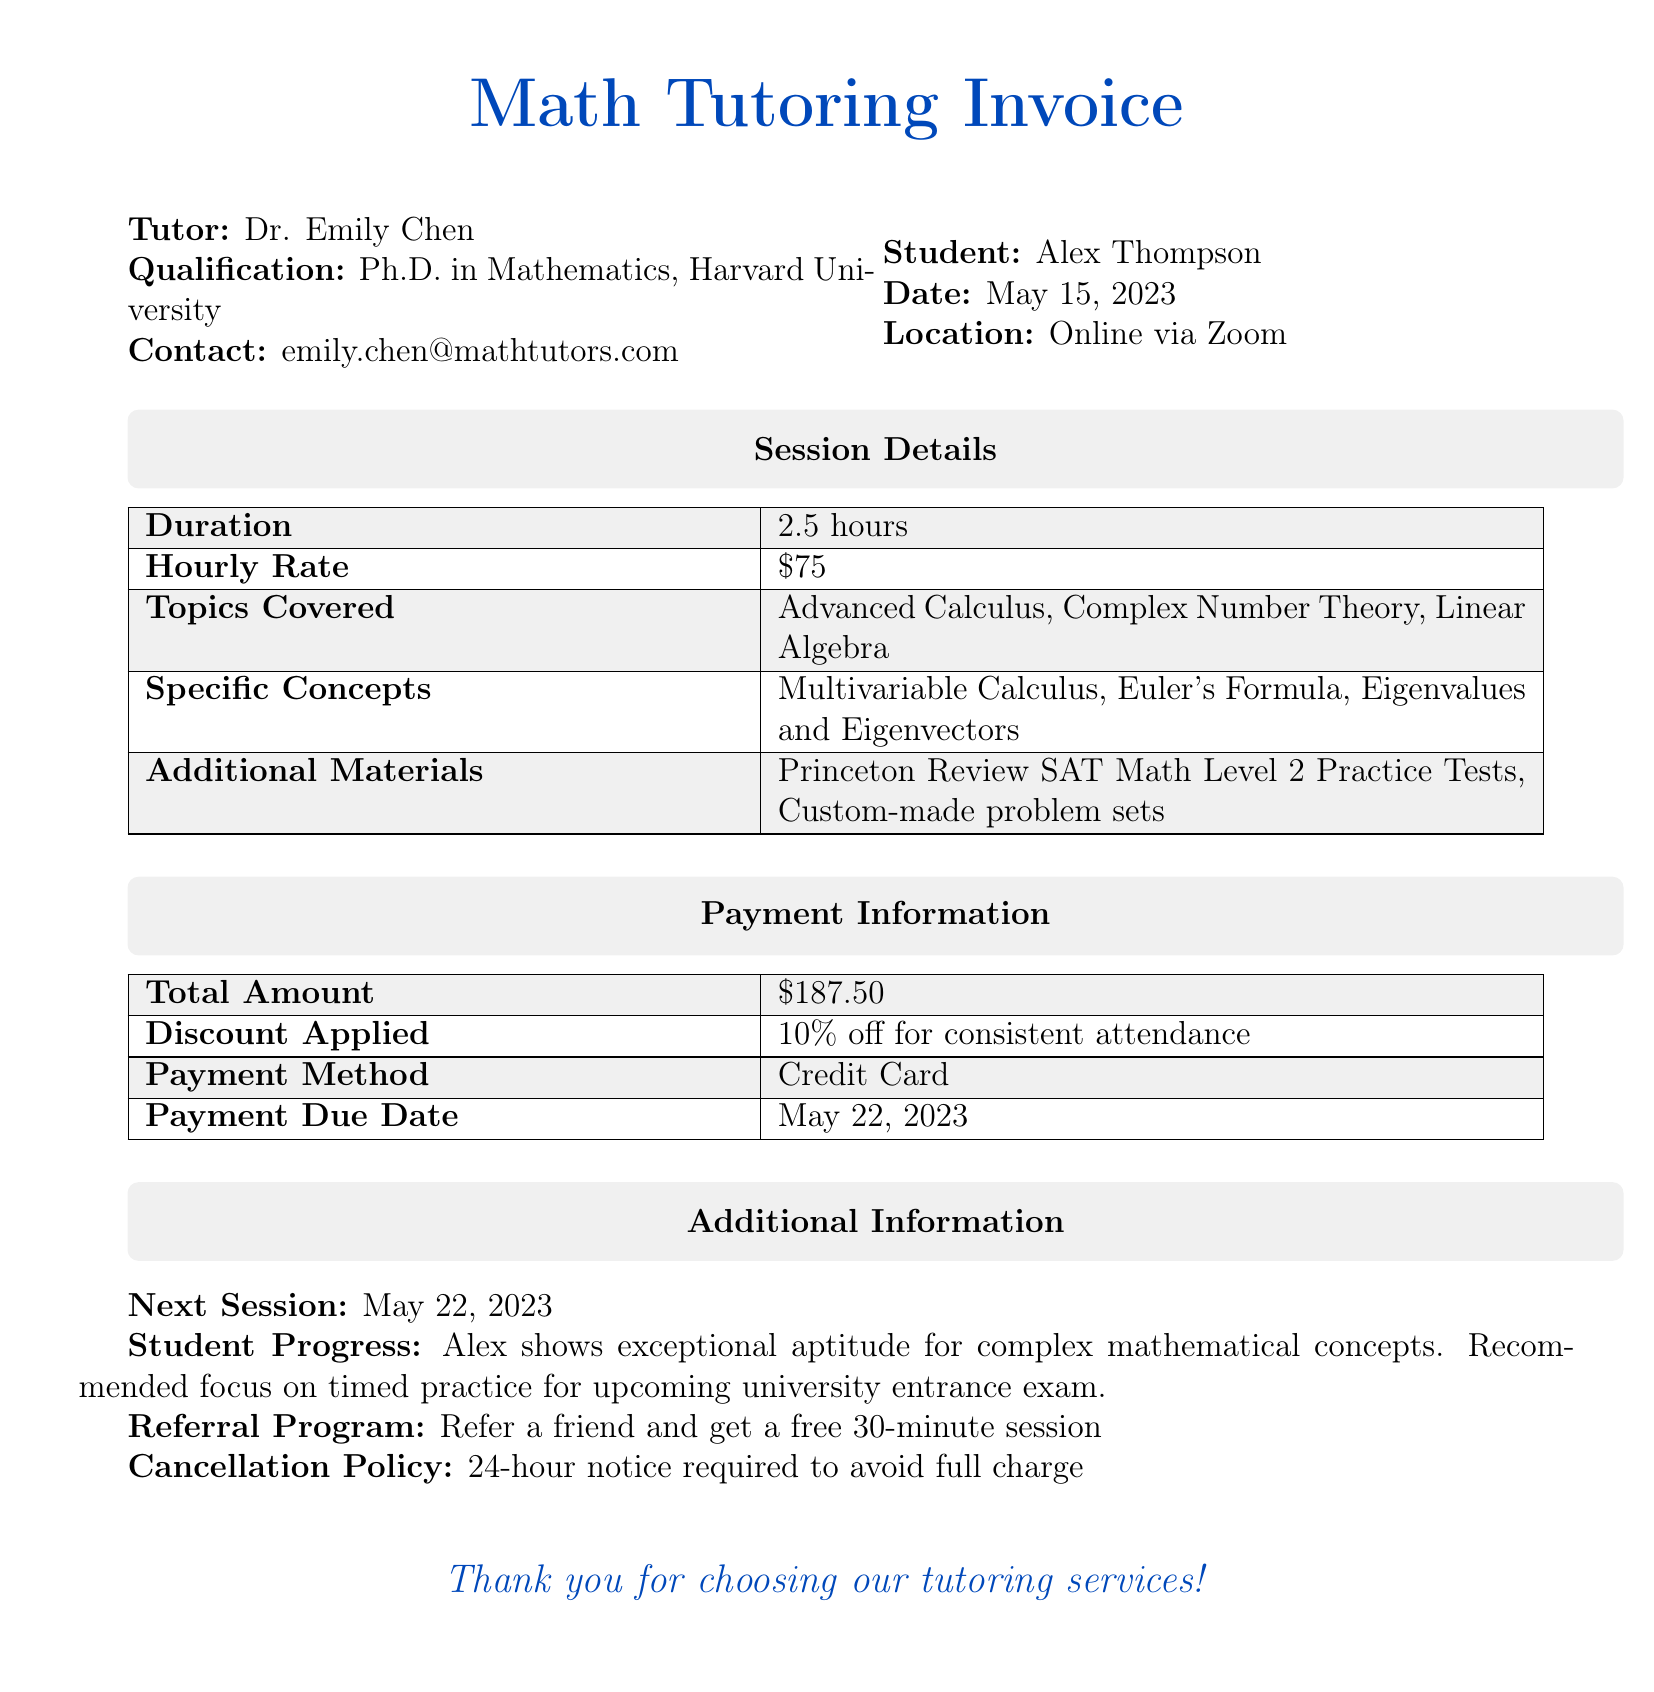What is the tutor's name? The tutor's name is clearly stated in the document.
Answer: Dr. Emily Chen What is the hourly rate? The document specifies the hourly rate for the tutoring session.
Answer: $75 What topics were covered in the session? The document lists the topics that were covered during the tutoring session.
Answer: Advanced Calculus, Complex Number Theory, Linear Algebra What is the total amount billed? The total amount for the tutoring session is provided in the payment information section.
Answer: $187.50 What was the duration of the tutoring session? The duration of the session is mentioned explicitly in the document.
Answer: 2.5 hours When is the payment due? The document specifies the date by which the payment should be made.
Answer: May 22, 2023 What discount was applied? The discount information is included in the payment details section of the document.
Answer: 10% off for consistent attendance What is included in the additional materials? The document provides a list of additional materials provided for the session.
Answer: Princeton Review SAT Math Level 2 Practice Tests, Custom-made problem sets What is the next session date? The next session date is clearly outlined in the additional information section of the document.
Answer: May 22, 2023 